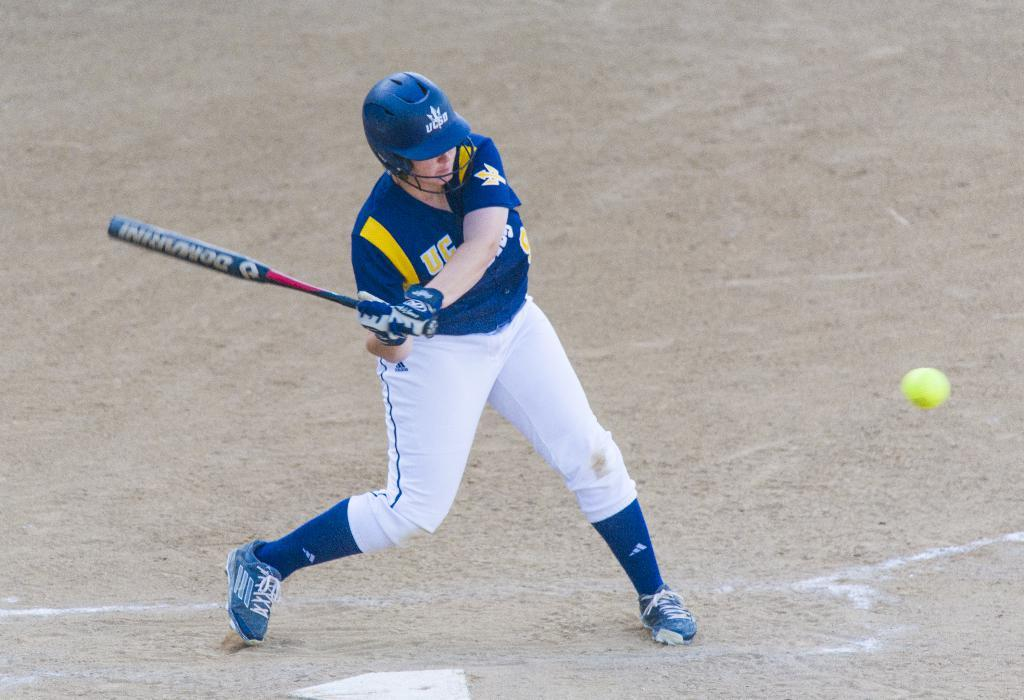Who or what is present in the image? There is a person in the image. What is the person wearing? The person is wearing a helmet. What object is the person holding? The person is holding a baseball bat. What other baseball-related item can be seen in the image? There is a baseball in the image. What type of terrain is visible in the background of the image? There is sand visible in the background of the image. How many legs does the bed have in the image? There is no bed present in the image. 